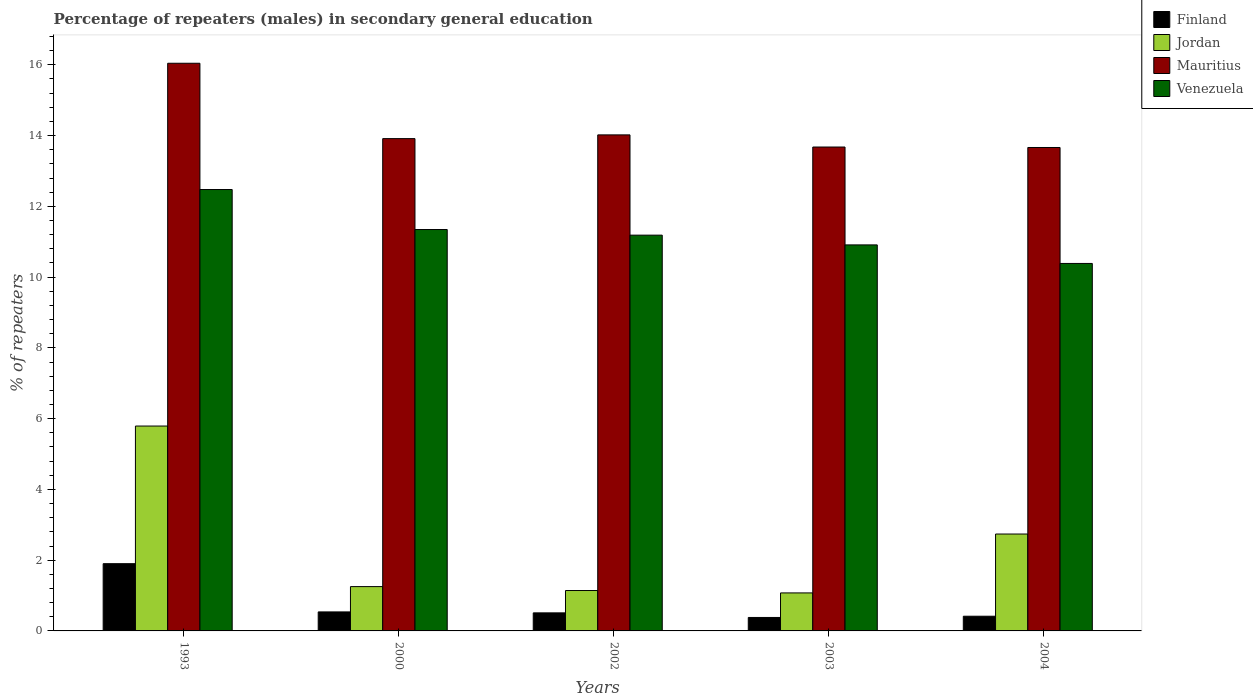How many different coloured bars are there?
Give a very brief answer. 4. Are the number of bars per tick equal to the number of legend labels?
Provide a short and direct response. Yes. Are the number of bars on each tick of the X-axis equal?
Ensure brevity in your answer.  Yes. How many bars are there on the 1st tick from the left?
Ensure brevity in your answer.  4. How many bars are there on the 4th tick from the right?
Offer a very short reply. 4. In how many cases, is the number of bars for a given year not equal to the number of legend labels?
Keep it short and to the point. 0. What is the percentage of male repeaters in Jordan in 2004?
Offer a terse response. 2.74. Across all years, what is the maximum percentage of male repeaters in Finland?
Ensure brevity in your answer.  1.9. Across all years, what is the minimum percentage of male repeaters in Venezuela?
Your answer should be very brief. 10.39. In which year was the percentage of male repeaters in Finland maximum?
Keep it short and to the point. 1993. In which year was the percentage of male repeaters in Jordan minimum?
Make the answer very short. 2003. What is the total percentage of male repeaters in Jordan in the graph?
Give a very brief answer. 12. What is the difference between the percentage of male repeaters in Venezuela in 2002 and that in 2003?
Give a very brief answer. 0.28. What is the difference between the percentage of male repeaters in Venezuela in 1993 and the percentage of male repeaters in Finland in 2004?
Provide a short and direct response. 12.06. What is the average percentage of male repeaters in Venezuela per year?
Offer a very short reply. 11.26. In the year 2003, what is the difference between the percentage of male repeaters in Finland and percentage of male repeaters in Jordan?
Offer a very short reply. -0.69. What is the ratio of the percentage of male repeaters in Jordan in 1993 to that in 2000?
Your answer should be very brief. 4.62. Is the percentage of male repeaters in Venezuela in 2002 less than that in 2004?
Provide a short and direct response. No. What is the difference between the highest and the second highest percentage of male repeaters in Venezuela?
Your answer should be very brief. 1.13. What is the difference between the highest and the lowest percentage of male repeaters in Jordan?
Make the answer very short. 4.72. In how many years, is the percentage of male repeaters in Mauritius greater than the average percentage of male repeaters in Mauritius taken over all years?
Keep it short and to the point. 1. What does the 4th bar from the left in 2002 represents?
Make the answer very short. Venezuela. What does the 1st bar from the right in 2000 represents?
Make the answer very short. Venezuela. How many bars are there?
Offer a very short reply. 20. Are the values on the major ticks of Y-axis written in scientific E-notation?
Your answer should be very brief. No. Does the graph contain grids?
Offer a terse response. No. Where does the legend appear in the graph?
Ensure brevity in your answer.  Top right. How many legend labels are there?
Keep it short and to the point. 4. How are the legend labels stacked?
Your answer should be compact. Vertical. What is the title of the graph?
Your answer should be very brief. Percentage of repeaters (males) in secondary general education. Does "Canada" appear as one of the legend labels in the graph?
Make the answer very short. No. What is the label or title of the X-axis?
Make the answer very short. Years. What is the label or title of the Y-axis?
Your answer should be compact. % of repeaters. What is the % of repeaters of Finland in 1993?
Provide a short and direct response. 1.9. What is the % of repeaters in Jordan in 1993?
Your answer should be very brief. 5.79. What is the % of repeaters of Mauritius in 1993?
Provide a succinct answer. 16.04. What is the % of repeaters of Venezuela in 1993?
Give a very brief answer. 12.48. What is the % of repeaters in Finland in 2000?
Keep it short and to the point. 0.54. What is the % of repeaters in Jordan in 2000?
Make the answer very short. 1.25. What is the % of repeaters of Mauritius in 2000?
Keep it short and to the point. 13.91. What is the % of repeaters in Venezuela in 2000?
Provide a succinct answer. 11.34. What is the % of repeaters of Finland in 2002?
Ensure brevity in your answer.  0.51. What is the % of repeaters in Jordan in 2002?
Offer a terse response. 1.14. What is the % of repeaters of Mauritius in 2002?
Your response must be concise. 14.02. What is the % of repeaters of Venezuela in 2002?
Give a very brief answer. 11.19. What is the % of repeaters in Finland in 2003?
Offer a terse response. 0.38. What is the % of repeaters of Jordan in 2003?
Your answer should be very brief. 1.07. What is the % of repeaters of Mauritius in 2003?
Your response must be concise. 13.68. What is the % of repeaters of Venezuela in 2003?
Your answer should be very brief. 10.91. What is the % of repeaters of Finland in 2004?
Provide a short and direct response. 0.42. What is the % of repeaters in Jordan in 2004?
Provide a succinct answer. 2.74. What is the % of repeaters of Mauritius in 2004?
Your answer should be very brief. 13.66. What is the % of repeaters of Venezuela in 2004?
Ensure brevity in your answer.  10.39. Across all years, what is the maximum % of repeaters in Finland?
Your answer should be compact. 1.9. Across all years, what is the maximum % of repeaters of Jordan?
Keep it short and to the point. 5.79. Across all years, what is the maximum % of repeaters in Mauritius?
Provide a succinct answer. 16.04. Across all years, what is the maximum % of repeaters of Venezuela?
Your answer should be compact. 12.48. Across all years, what is the minimum % of repeaters of Finland?
Offer a very short reply. 0.38. Across all years, what is the minimum % of repeaters of Jordan?
Your answer should be very brief. 1.07. Across all years, what is the minimum % of repeaters of Mauritius?
Your answer should be compact. 13.66. Across all years, what is the minimum % of repeaters in Venezuela?
Give a very brief answer. 10.39. What is the total % of repeaters of Finland in the graph?
Ensure brevity in your answer.  3.74. What is the total % of repeaters in Jordan in the graph?
Make the answer very short. 12. What is the total % of repeaters of Mauritius in the graph?
Give a very brief answer. 71.32. What is the total % of repeaters in Venezuela in the graph?
Offer a terse response. 56.3. What is the difference between the % of repeaters in Finland in 1993 and that in 2000?
Offer a very short reply. 1.36. What is the difference between the % of repeaters of Jordan in 1993 and that in 2000?
Provide a short and direct response. 4.54. What is the difference between the % of repeaters of Mauritius in 1993 and that in 2000?
Offer a terse response. 2.13. What is the difference between the % of repeaters in Venezuela in 1993 and that in 2000?
Give a very brief answer. 1.13. What is the difference between the % of repeaters in Finland in 1993 and that in 2002?
Give a very brief answer. 1.39. What is the difference between the % of repeaters in Jordan in 1993 and that in 2002?
Make the answer very short. 4.65. What is the difference between the % of repeaters in Mauritius in 1993 and that in 2002?
Give a very brief answer. 2.02. What is the difference between the % of repeaters in Venezuela in 1993 and that in 2002?
Make the answer very short. 1.29. What is the difference between the % of repeaters in Finland in 1993 and that in 2003?
Provide a succinct answer. 1.52. What is the difference between the % of repeaters of Jordan in 1993 and that in 2003?
Your answer should be very brief. 4.72. What is the difference between the % of repeaters in Mauritius in 1993 and that in 2003?
Ensure brevity in your answer.  2.37. What is the difference between the % of repeaters of Venezuela in 1993 and that in 2003?
Give a very brief answer. 1.57. What is the difference between the % of repeaters in Finland in 1993 and that in 2004?
Give a very brief answer. 1.49. What is the difference between the % of repeaters in Jordan in 1993 and that in 2004?
Ensure brevity in your answer.  3.05. What is the difference between the % of repeaters in Mauritius in 1993 and that in 2004?
Provide a short and direct response. 2.38. What is the difference between the % of repeaters in Venezuela in 1993 and that in 2004?
Give a very brief answer. 2.09. What is the difference between the % of repeaters in Finland in 2000 and that in 2002?
Offer a very short reply. 0.03. What is the difference between the % of repeaters in Jordan in 2000 and that in 2002?
Keep it short and to the point. 0.11. What is the difference between the % of repeaters in Mauritius in 2000 and that in 2002?
Your response must be concise. -0.11. What is the difference between the % of repeaters in Venezuela in 2000 and that in 2002?
Give a very brief answer. 0.16. What is the difference between the % of repeaters of Finland in 2000 and that in 2003?
Provide a short and direct response. 0.16. What is the difference between the % of repeaters of Jordan in 2000 and that in 2003?
Make the answer very short. 0.18. What is the difference between the % of repeaters of Mauritius in 2000 and that in 2003?
Ensure brevity in your answer.  0.24. What is the difference between the % of repeaters in Venezuela in 2000 and that in 2003?
Provide a short and direct response. 0.43. What is the difference between the % of repeaters in Finland in 2000 and that in 2004?
Your answer should be very brief. 0.12. What is the difference between the % of repeaters in Jordan in 2000 and that in 2004?
Provide a succinct answer. -1.49. What is the difference between the % of repeaters in Mauritius in 2000 and that in 2004?
Provide a succinct answer. 0.25. What is the difference between the % of repeaters of Venezuela in 2000 and that in 2004?
Your answer should be compact. 0.96. What is the difference between the % of repeaters of Finland in 2002 and that in 2003?
Make the answer very short. 0.13. What is the difference between the % of repeaters of Jordan in 2002 and that in 2003?
Provide a short and direct response. 0.07. What is the difference between the % of repeaters of Mauritius in 2002 and that in 2003?
Make the answer very short. 0.34. What is the difference between the % of repeaters in Venezuela in 2002 and that in 2003?
Provide a succinct answer. 0.28. What is the difference between the % of repeaters of Finland in 2002 and that in 2004?
Provide a succinct answer. 0.09. What is the difference between the % of repeaters in Jordan in 2002 and that in 2004?
Make the answer very short. -1.6. What is the difference between the % of repeaters of Mauritius in 2002 and that in 2004?
Your answer should be compact. 0.36. What is the difference between the % of repeaters of Venezuela in 2002 and that in 2004?
Your response must be concise. 0.8. What is the difference between the % of repeaters of Finland in 2003 and that in 2004?
Ensure brevity in your answer.  -0.04. What is the difference between the % of repeaters of Jordan in 2003 and that in 2004?
Keep it short and to the point. -1.66. What is the difference between the % of repeaters in Mauritius in 2003 and that in 2004?
Your answer should be compact. 0.01. What is the difference between the % of repeaters in Venezuela in 2003 and that in 2004?
Ensure brevity in your answer.  0.52. What is the difference between the % of repeaters of Finland in 1993 and the % of repeaters of Jordan in 2000?
Make the answer very short. 0.65. What is the difference between the % of repeaters of Finland in 1993 and the % of repeaters of Mauritius in 2000?
Offer a terse response. -12.01. What is the difference between the % of repeaters of Finland in 1993 and the % of repeaters of Venezuela in 2000?
Your response must be concise. -9.44. What is the difference between the % of repeaters of Jordan in 1993 and the % of repeaters of Mauritius in 2000?
Provide a succinct answer. -8.12. What is the difference between the % of repeaters of Jordan in 1993 and the % of repeaters of Venezuela in 2000?
Ensure brevity in your answer.  -5.55. What is the difference between the % of repeaters in Mauritius in 1993 and the % of repeaters in Venezuela in 2000?
Your answer should be compact. 4.7. What is the difference between the % of repeaters of Finland in 1993 and the % of repeaters of Jordan in 2002?
Make the answer very short. 0.76. What is the difference between the % of repeaters of Finland in 1993 and the % of repeaters of Mauritius in 2002?
Make the answer very short. -12.12. What is the difference between the % of repeaters of Finland in 1993 and the % of repeaters of Venezuela in 2002?
Your response must be concise. -9.29. What is the difference between the % of repeaters of Jordan in 1993 and the % of repeaters of Mauritius in 2002?
Provide a short and direct response. -8.23. What is the difference between the % of repeaters of Jordan in 1993 and the % of repeaters of Venezuela in 2002?
Your answer should be very brief. -5.4. What is the difference between the % of repeaters in Mauritius in 1993 and the % of repeaters in Venezuela in 2002?
Offer a very short reply. 4.86. What is the difference between the % of repeaters of Finland in 1993 and the % of repeaters of Jordan in 2003?
Your answer should be compact. 0.83. What is the difference between the % of repeaters in Finland in 1993 and the % of repeaters in Mauritius in 2003?
Offer a terse response. -11.78. What is the difference between the % of repeaters in Finland in 1993 and the % of repeaters in Venezuela in 2003?
Your answer should be compact. -9.01. What is the difference between the % of repeaters of Jordan in 1993 and the % of repeaters of Mauritius in 2003?
Offer a very short reply. -7.89. What is the difference between the % of repeaters in Jordan in 1993 and the % of repeaters in Venezuela in 2003?
Provide a succinct answer. -5.12. What is the difference between the % of repeaters in Mauritius in 1993 and the % of repeaters in Venezuela in 2003?
Offer a very short reply. 5.13. What is the difference between the % of repeaters of Finland in 1993 and the % of repeaters of Jordan in 2004?
Give a very brief answer. -0.84. What is the difference between the % of repeaters of Finland in 1993 and the % of repeaters of Mauritius in 2004?
Your answer should be compact. -11.76. What is the difference between the % of repeaters of Finland in 1993 and the % of repeaters of Venezuela in 2004?
Your answer should be compact. -8.49. What is the difference between the % of repeaters of Jordan in 1993 and the % of repeaters of Mauritius in 2004?
Provide a short and direct response. -7.87. What is the difference between the % of repeaters in Jordan in 1993 and the % of repeaters in Venezuela in 2004?
Make the answer very short. -4.6. What is the difference between the % of repeaters in Mauritius in 1993 and the % of repeaters in Venezuela in 2004?
Your answer should be very brief. 5.66. What is the difference between the % of repeaters of Finland in 2000 and the % of repeaters of Jordan in 2002?
Your response must be concise. -0.6. What is the difference between the % of repeaters in Finland in 2000 and the % of repeaters in Mauritius in 2002?
Provide a short and direct response. -13.48. What is the difference between the % of repeaters in Finland in 2000 and the % of repeaters in Venezuela in 2002?
Your answer should be very brief. -10.65. What is the difference between the % of repeaters of Jordan in 2000 and the % of repeaters of Mauritius in 2002?
Offer a very short reply. -12.77. What is the difference between the % of repeaters of Jordan in 2000 and the % of repeaters of Venezuela in 2002?
Offer a terse response. -9.93. What is the difference between the % of repeaters in Mauritius in 2000 and the % of repeaters in Venezuela in 2002?
Your answer should be very brief. 2.73. What is the difference between the % of repeaters in Finland in 2000 and the % of repeaters in Jordan in 2003?
Offer a terse response. -0.54. What is the difference between the % of repeaters of Finland in 2000 and the % of repeaters of Mauritius in 2003?
Your answer should be very brief. -13.14. What is the difference between the % of repeaters of Finland in 2000 and the % of repeaters of Venezuela in 2003?
Ensure brevity in your answer.  -10.37. What is the difference between the % of repeaters of Jordan in 2000 and the % of repeaters of Mauritius in 2003?
Ensure brevity in your answer.  -12.42. What is the difference between the % of repeaters in Jordan in 2000 and the % of repeaters in Venezuela in 2003?
Give a very brief answer. -9.66. What is the difference between the % of repeaters in Mauritius in 2000 and the % of repeaters in Venezuela in 2003?
Provide a succinct answer. 3. What is the difference between the % of repeaters in Finland in 2000 and the % of repeaters in Jordan in 2004?
Offer a terse response. -2.2. What is the difference between the % of repeaters of Finland in 2000 and the % of repeaters of Mauritius in 2004?
Ensure brevity in your answer.  -13.13. What is the difference between the % of repeaters of Finland in 2000 and the % of repeaters of Venezuela in 2004?
Your answer should be very brief. -9.85. What is the difference between the % of repeaters in Jordan in 2000 and the % of repeaters in Mauritius in 2004?
Your response must be concise. -12.41. What is the difference between the % of repeaters in Jordan in 2000 and the % of repeaters in Venezuela in 2004?
Your answer should be very brief. -9.13. What is the difference between the % of repeaters in Mauritius in 2000 and the % of repeaters in Venezuela in 2004?
Your response must be concise. 3.53. What is the difference between the % of repeaters in Finland in 2002 and the % of repeaters in Jordan in 2003?
Offer a terse response. -0.56. What is the difference between the % of repeaters in Finland in 2002 and the % of repeaters in Mauritius in 2003?
Offer a terse response. -13.17. What is the difference between the % of repeaters of Finland in 2002 and the % of repeaters of Venezuela in 2003?
Provide a succinct answer. -10.4. What is the difference between the % of repeaters of Jordan in 2002 and the % of repeaters of Mauritius in 2003?
Keep it short and to the point. -12.53. What is the difference between the % of repeaters in Jordan in 2002 and the % of repeaters in Venezuela in 2003?
Make the answer very short. -9.77. What is the difference between the % of repeaters in Mauritius in 2002 and the % of repeaters in Venezuela in 2003?
Offer a terse response. 3.11. What is the difference between the % of repeaters in Finland in 2002 and the % of repeaters in Jordan in 2004?
Offer a terse response. -2.23. What is the difference between the % of repeaters in Finland in 2002 and the % of repeaters in Mauritius in 2004?
Offer a very short reply. -13.15. What is the difference between the % of repeaters in Finland in 2002 and the % of repeaters in Venezuela in 2004?
Make the answer very short. -9.88. What is the difference between the % of repeaters of Jordan in 2002 and the % of repeaters of Mauritius in 2004?
Give a very brief answer. -12.52. What is the difference between the % of repeaters in Jordan in 2002 and the % of repeaters in Venezuela in 2004?
Give a very brief answer. -9.24. What is the difference between the % of repeaters of Mauritius in 2002 and the % of repeaters of Venezuela in 2004?
Your answer should be very brief. 3.63. What is the difference between the % of repeaters of Finland in 2003 and the % of repeaters of Jordan in 2004?
Provide a succinct answer. -2.36. What is the difference between the % of repeaters in Finland in 2003 and the % of repeaters in Mauritius in 2004?
Your answer should be compact. -13.28. What is the difference between the % of repeaters of Finland in 2003 and the % of repeaters of Venezuela in 2004?
Keep it short and to the point. -10.01. What is the difference between the % of repeaters in Jordan in 2003 and the % of repeaters in Mauritius in 2004?
Your response must be concise. -12.59. What is the difference between the % of repeaters in Jordan in 2003 and the % of repeaters in Venezuela in 2004?
Your answer should be very brief. -9.31. What is the difference between the % of repeaters of Mauritius in 2003 and the % of repeaters of Venezuela in 2004?
Make the answer very short. 3.29. What is the average % of repeaters in Finland per year?
Your answer should be compact. 0.75. What is the average % of repeaters in Jordan per year?
Give a very brief answer. 2.4. What is the average % of repeaters of Mauritius per year?
Give a very brief answer. 14.26. What is the average % of repeaters in Venezuela per year?
Your answer should be very brief. 11.26. In the year 1993, what is the difference between the % of repeaters in Finland and % of repeaters in Jordan?
Your answer should be very brief. -3.89. In the year 1993, what is the difference between the % of repeaters in Finland and % of repeaters in Mauritius?
Provide a short and direct response. -14.14. In the year 1993, what is the difference between the % of repeaters of Finland and % of repeaters of Venezuela?
Your answer should be very brief. -10.57. In the year 1993, what is the difference between the % of repeaters in Jordan and % of repeaters in Mauritius?
Keep it short and to the point. -10.25. In the year 1993, what is the difference between the % of repeaters of Jordan and % of repeaters of Venezuela?
Your answer should be very brief. -6.68. In the year 1993, what is the difference between the % of repeaters of Mauritius and % of repeaters of Venezuela?
Provide a short and direct response. 3.57. In the year 2000, what is the difference between the % of repeaters in Finland and % of repeaters in Jordan?
Provide a succinct answer. -0.72. In the year 2000, what is the difference between the % of repeaters of Finland and % of repeaters of Mauritius?
Keep it short and to the point. -13.38. In the year 2000, what is the difference between the % of repeaters of Finland and % of repeaters of Venezuela?
Your response must be concise. -10.81. In the year 2000, what is the difference between the % of repeaters in Jordan and % of repeaters in Mauritius?
Your answer should be compact. -12.66. In the year 2000, what is the difference between the % of repeaters of Jordan and % of repeaters of Venezuela?
Provide a succinct answer. -10.09. In the year 2000, what is the difference between the % of repeaters in Mauritius and % of repeaters in Venezuela?
Offer a terse response. 2.57. In the year 2002, what is the difference between the % of repeaters in Finland and % of repeaters in Jordan?
Offer a very short reply. -0.63. In the year 2002, what is the difference between the % of repeaters of Finland and % of repeaters of Mauritius?
Your answer should be very brief. -13.51. In the year 2002, what is the difference between the % of repeaters in Finland and % of repeaters in Venezuela?
Your answer should be compact. -10.68. In the year 2002, what is the difference between the % of repeaters in Jordan and % of repeaters in Mauritius?
Your answer should be very brief. -12.88. In the year 2002, what is the difference between the % of repeaters of Jordan and % of repeaters of Venezuela?
Provide a succinct answer. -10.04. In the year 2002, what is the difference between the % of repeaters of Mauritius and % of repeaters of Venezuela?
Keep it short and to the point. 2.83. In the year 2003, what is the difference between the % of repeaters in Finland and % of repeaters in Jordan?
Give a very brief answer. -0.69. In the year 2003, what is the difference between the % of repeaters of Finland and % of repeaters of Mauritius?
Your answer should be very brief. -13.3. In the year 2003, what is the difference between the % of repeaters in Finland and % of repeaters in Venezuela?
Your response must be concise. -10.53. In the year 2003, what is the difference between the % of repeaters in Jordan and % of repeaters in Mauritius?
Provide a succinct answer. -12.6. In the year 2003, what is the difference between the % of repeaters in Jordan and % of repeaters in Venezuela?
Your answer should be compact. -9.84. In the year 2003, what is the difference between the % of repeaters in Mauritius and % of repeaters in Venezuela?
Your response must be concise. 2.77. In the year 2004, what is the difference between the % of repeaters in Finland and % of repeaters in Jordan?
Offer a terse response. -2.32. In the year 2004, what is the difference between the % of repeaters in Finland and % of repeaters in Mauritius?
Provide a succinct answer. -13.25. In the year 2004, what is the difference between the % of repeaters in Finland and % of repeaters in Venezuela?
Offer a terse response. -9.97. In the year 2004, what is the difference between the % of repeaters of Jordan and % of repeaters of Mauritius?
Offer a terse response. -10.92. In the year 2004, what is the difference between the % of repeaters of Jordan and % of repeaters of Venezuela?
Your answer should be very brief. -7.65. In the year 2004, what is the difference between the % of repeaters of Mauritius and % of repeaters of Venezuela?
Give a very brief answer. 3.28. What is the ratio of the % of repeaters in Finland in 1993 to that in 2000?
Your response must be concise. 3.54. What is the ratio of the % of repeaters in Jordan in 1993 to that in 2000?
Give a very brief answer. 4.62. What is the ratio of the % of repeaters in Mauritius in 1993 to that in 2000?
Your answer should be very brief. 1.15. What is the ratio of the % of repeaters in Venezuela in 1993 to that in 2000?
Offer a very short reply. 1.1. What is the ratio of the % of repeaters in Finland in 1993 to that in 2002?
Provide a short and direct response. 3.73. What is the ratio of the % of repeaters in Jordan in 1993 to that in 2002?
Give a very brief answer. 5.07. What is the ratio of the % of repeaters in Mauritius in 1993 to that in 2002?
Provide a short and direct response. 1.14. What is the ratio of the % of repeaters of Venezuela in 1993 to that in 2002?
Offer a very short reply. 1.12. What is the ratio of the % of repeaters in Finland in 1993 to that in 2003?
Make the answer very short. 4.99. What is the ratio of the % of repeaters of Jordan in 1993 to that in 2003?
Make the answer very short. 5.39. What is the ratio of the % of repeaters of Mauritius in 1993 to that in 2003?
Offer a very short reply. 1.17. What is the ratio of the % of repeaters of Venezuela in 1993 to that in 2003?
Ensure brevity in your answer.  1.14. What is the ratio of the % of repeaters in Finland in 1993 to that in 2004?
Ensure brevity in your answer.  4.57. What is the ratio of the % of repeaters of Jordan in 1993 to that in 2004?
Provide a short and direct response. 2.11. What is the ratio of the % of repeaters of Mauritius in 1993 to that in 2004?
Provide a succinct answer. 1.17. What is the ratio of the % of repeaters in Venezuela in 1993 to that in 2004?
Your answer should be compact. 1.2. What is the ratio of the % of repeaters of Finland in 2000 to that in 2002?
Your response must be concise. 1.05. What is the ratio of the % of repeaters of Jordan in 2000 to that in 2002?
Your answer should be very brief. 1.1. What is the ratio of the % of repeaters of Venezuela in 2000 to that in 2002?
Provide a succinct answer. 1.01. What is the ratio of the % of repeaters in Finland in 2000 to that in 2003?
Offer a very short reply. 1.41. What is the ratio of the % of repeaters of Jordan in 2000 to that in 2003?
Your answer should be compact. 1.17. What is the ratio of the % of repeaters in Mauritius in 2000 to that in 2003?
Provide a succinct answer. 1.02. What is the ratio of the % of repeaters of Venezuela in 2000 to that in 2003?
Offer a very short reply. 1.04. What is the ratio of the % of repeaters of Finland in 2000 to that in 2004?
Your answer should be compact. 1.29. What is the ratio of the % of repeaters in Jordan in 2000 to that in 2004?
Your answer should be very brief. 0.46. What is the ratio of the % of repeaters of Mauritius in 2000 to that in 2004?
Offer a very short reply. 1.02. What is the ratio of the % of repeaters in Venezuela in 2000 to that in 2004?
Ensure brevity in your answer.  1.09. What is the ratio of the % of repeaters in Finland in 2002 to that in 2003?
Provide a succinct answer. 1.34. What is the ratio of the % of repeaters of Jordan in 2002 to that in 2003?
Give a very brief answer. 1.06. What is the ratio of the % of repeaters in Mauritius in 2002 to that in 2003?
Offer a very short reply. 1.03. What is the ratio of the % of repeaters in Venezuela in 2002 to that in 2003?
Your answer should be compact. 1.03. What is the ratio of the % of repeaters of Finland in 2002 to that in 2004?
Provide a succinct answer. 1.23. What is the ratio of the % of repeaters of Jordan in 2002 to that in 2004?
Your answer should be compact. 0.42. What is the ratio of the % of repeaters of Mauritius in 2002 to that in 2004?
Your answer should be compact. 1.03. What is the ratio of the % of repeaters in Venezuela in 2002 to that in 2004?
Provide a succinct answer. 1.08. What is the ratio of the % of repeaters in Finland in 2003 to that in 2004?
Your answer should be very brief. 0.92. What is the ratio of the % of repeaters in Jordan in 2003 to that in 2004?
Your answer should be compact. 0.39. What is the ratio of the % of repeaters in Venezuela in 2003 to that in 2004?
Ensure brevity in your answer.  1.05. What is the difference between the highest and the second highest % of repeaters in Finland?
Ensure brevity in your answer.  1.36. What is the difference between the highest and the second highest % of repeaters of Jordan?
Offer a terse response. 3.05. What is the difference between the highest and the second highest % of repeaters in Mauritius?
Provide a short and direct response. 2.02. What is the difference between the highest and the second highest % of repeaters in Venezuela?
Your answer should be compact. 1.13. What is the difference between the highest and the lowest % of repeaters of Finland?
Ensure brevity in your answer.  1.52. What is the difference between the highest and the lowest % of repeaters in Jordan?
Ensure brevity in your answer.  4.72. What is the difference between the highest and the lowest % of repeaters in Mauritius?
Your response must be concise. 2.38. What is the difference between the highest and the lowest % of repeaters in Venezuela?
Your answer should be very brief. 2.09. 